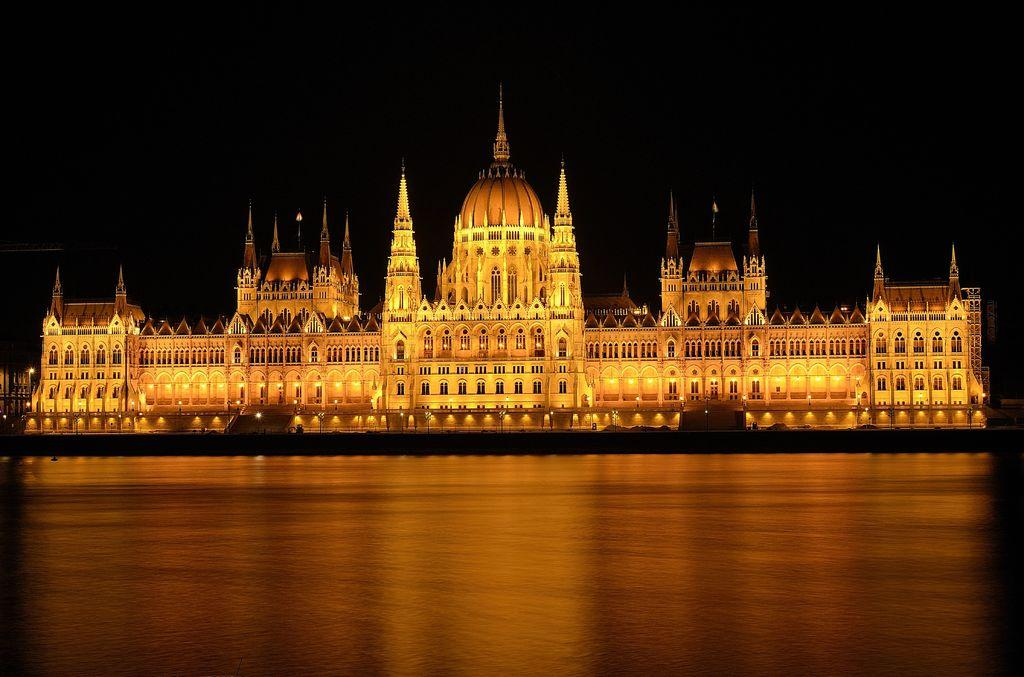What is the main structure in the center of the image? There is a palace in the center of the image. What can be seen illuminating the palace? There are lights in the image. What is located at the bottom of the image? There is a walkway at the bottom of the image. How would you describe the overall lighting in the image? The background of the image is dark. What book is the palace reading in the image? There is no book present in the image, and palaces do not read books. 